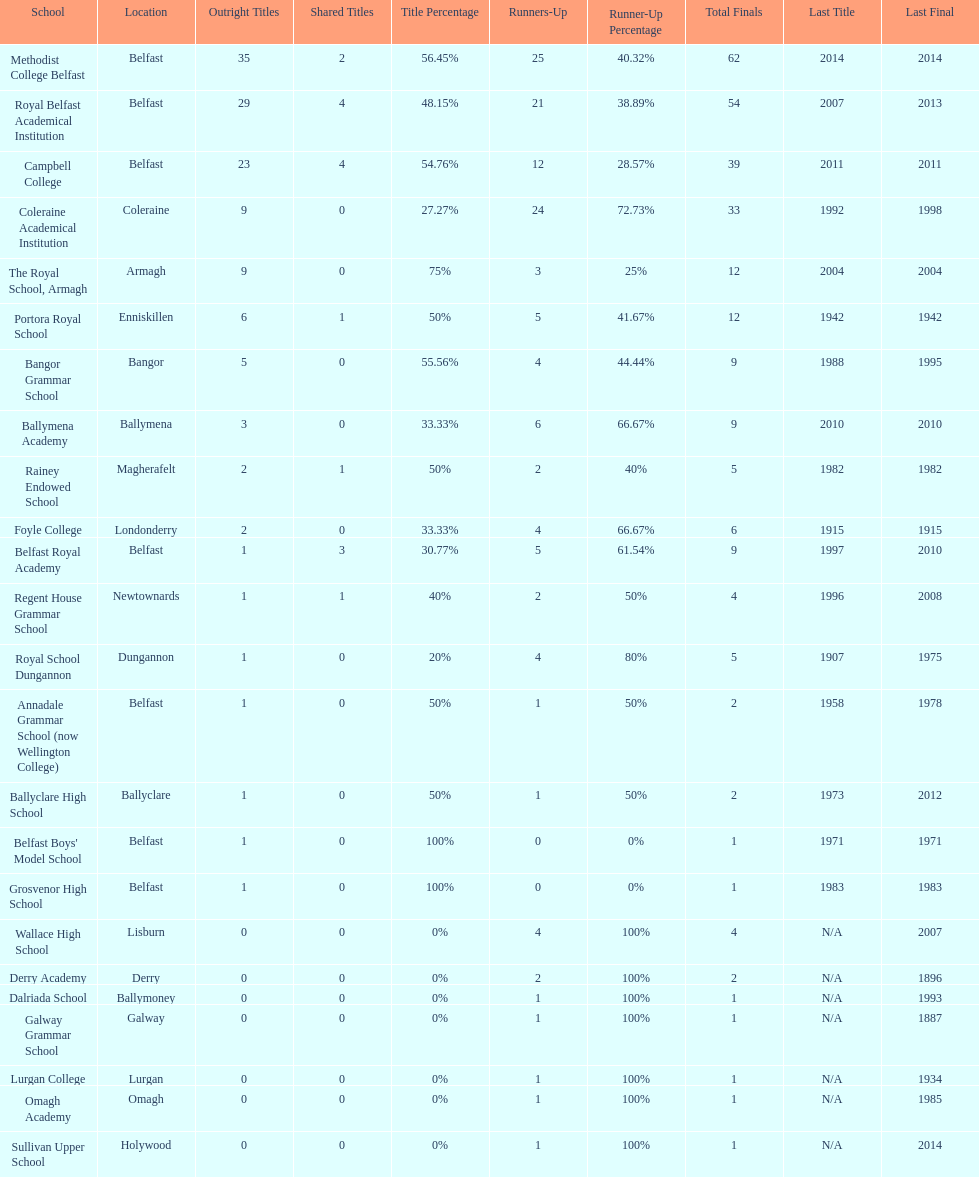Did belfast royal academy have more or less total finals than ballyclare high school? More. 